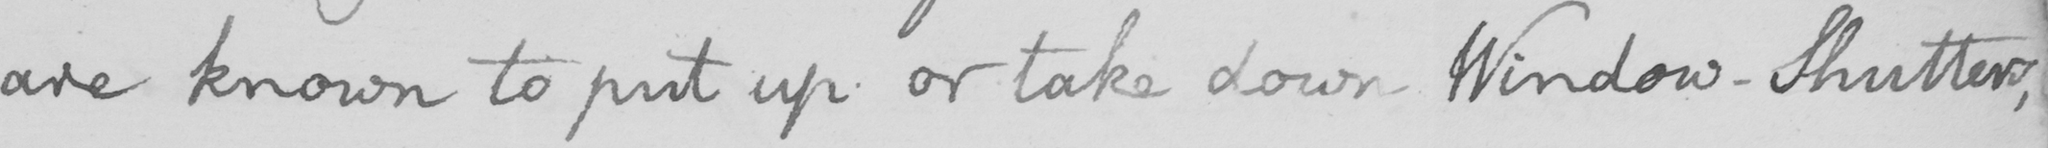Please provide the text content of this handwritten line. are known to put up or take down Window-Shutters , 